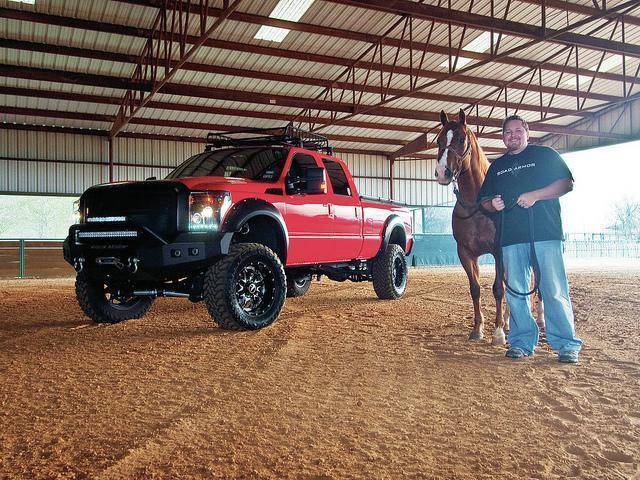How many characters on the digitized reader board on the top front of the bus are numerals?
Give a very brief answer. 0. 